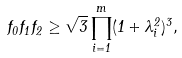Convert formula to latex. <formula><loc_0><loc_0><loc_500><loc_500>f _ { 0 } f _ { 1 } f _ { 2 } \geq \sqrt { 3 } \prod _ { i = 1 } ^ { m } ( 1 + \lambda _ { i } ^ { 2 } ) ^ { 3 } ,</formula> 